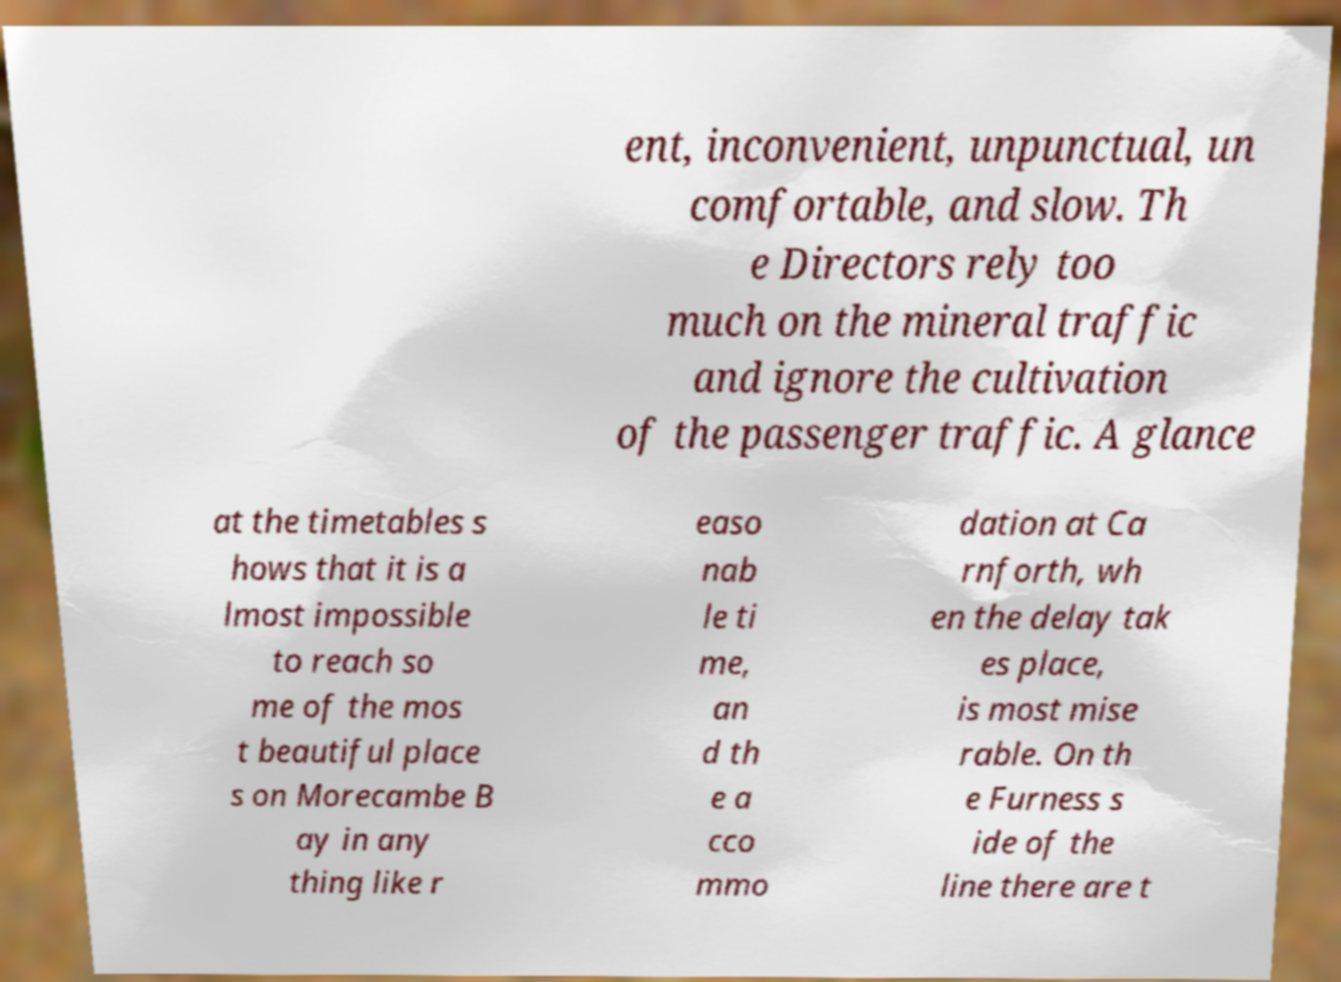There's text embedded in this image that I need extracted. Can you transcribe it verbatim? ent, inconvenient, unpunctual, un comfortable, and slow. Th e Directors rely too much on the mineral traffic and ignore the cultivation of the passenger traffic. A glance at the timetables s hows that it is a lmost impossible to reach so me of the mos t beautiful place s on Morecambe B ay in any thing like r easo nab le ti me, an d th e a cco mmo dation at Ca rnforth, wh en the delay tak es place, is most mise rable. On th e Furness s ide of the line there are t 